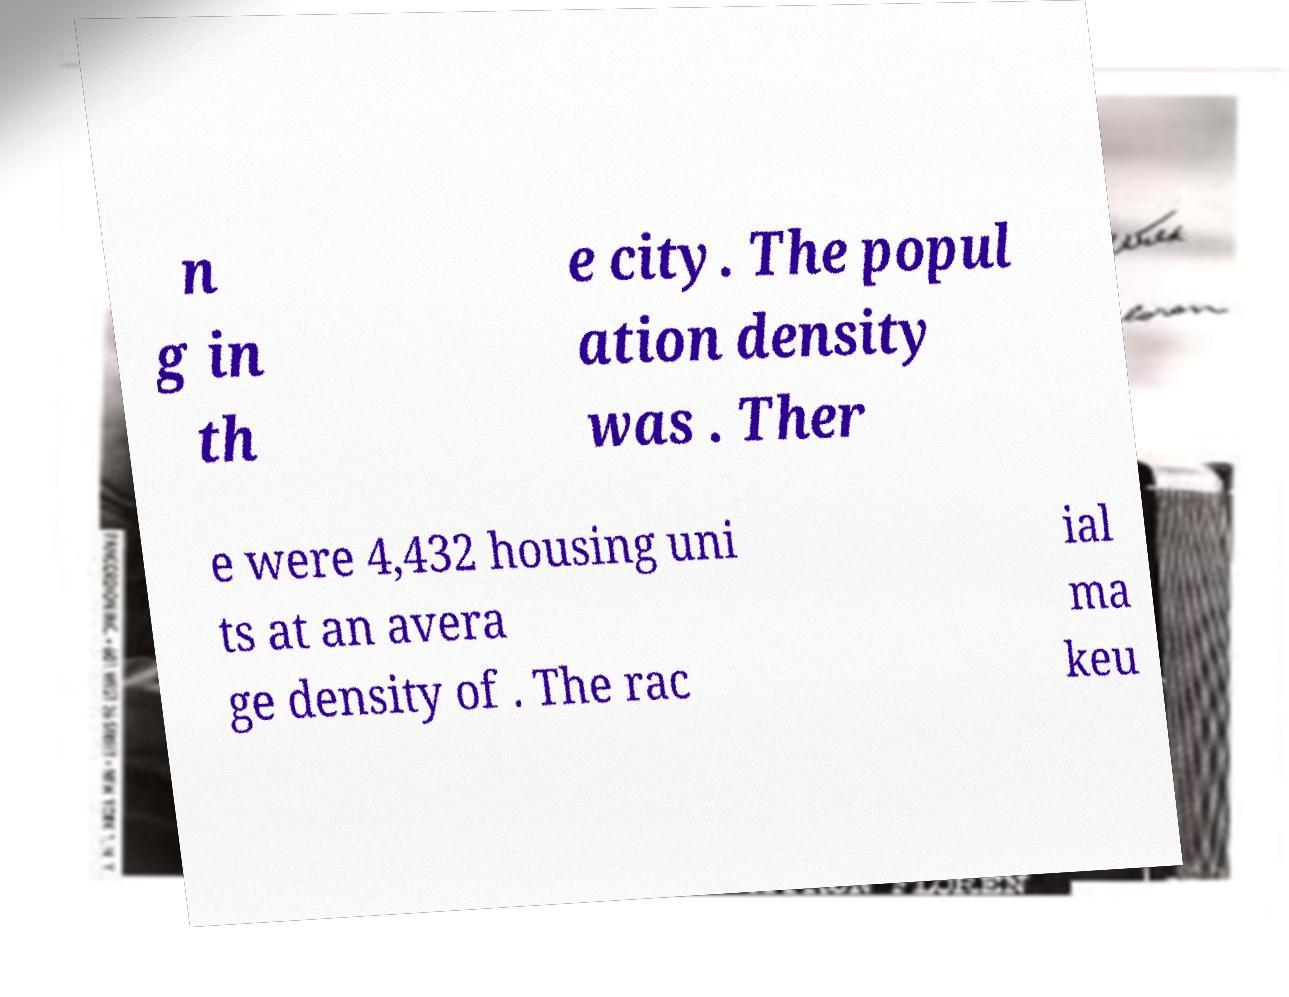I need the written content from this picture converted into text. Can you do that? n g in th e city. The popul ation density was . Ther e were 4,432 housing uni ts at an avera ge density of . The rac ial ma keu 